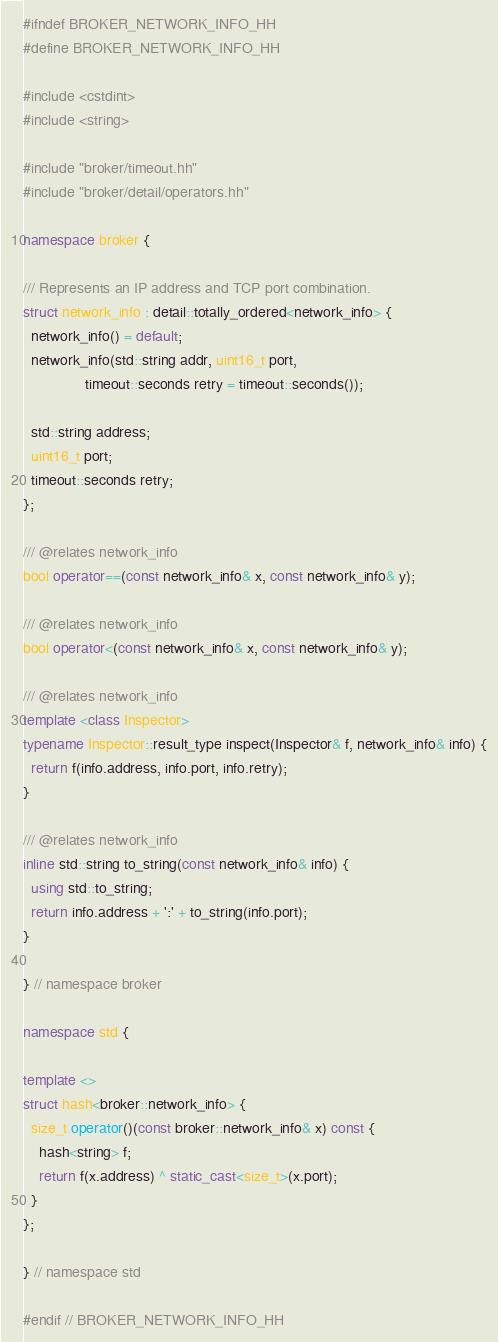<code> <loc_0><loc_0><loc_500><loc_500><_C++_>#ifndef BROKER_NETWORK_INFO_HH
#define BROKER_NETWORK_INFO_HH

#include <cstdint>
#include <string>

#include "broker/timeout.hh"
#include "broker/detail/operators.hh"

namespace broker {

/// Represents an IP address and TCP port combination.
struct network_info : detail::totally_ordered<network_info> {
  network_info() = default;
  network_info(std::string addr, uint16_t port,
               timeout::seconds retry = timeout::seconds());

  std::string address;
  uint16_t port;
  timeout::seconds retry;
};

/// @relates network_info
bool operator==(const network_info& x, const network_info& y);

/// @relates network_info
bool operator<(const network_info& x, const network_info& y);

/// @relates network_info
template <class Inspector>
typename Inspector::result_type inspect(Inspector& f, network_info& info) {
  return f(info.address, info.port, info.retry);
}

/// @relates network_info
inline std::string to_string(const network_info& info) {
  using std::to_string;
  return info.address + ':' + to_string(info.port);
}

} // namespace broker

namespace std {

template <>
struct hash<broker::network_info> {
  size_t operator()(const broker::network_info& x) const {
    hash<string> f;
    return f(x.address) ^ static_cast<size_t>(x.port);
  }
};

} // namespace std

#endif // BROKER_NETWORK_INFO_HH
</code> 